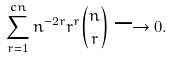Convert formula to latex. <formula><loc_0><loc_0><loc_500><loc_500>\sum _ { r = 1 } ^ { c n } n ^ { - 2 r } r ^ { r } \binom { n } { r } \longrightarrow 0 .</formula> 